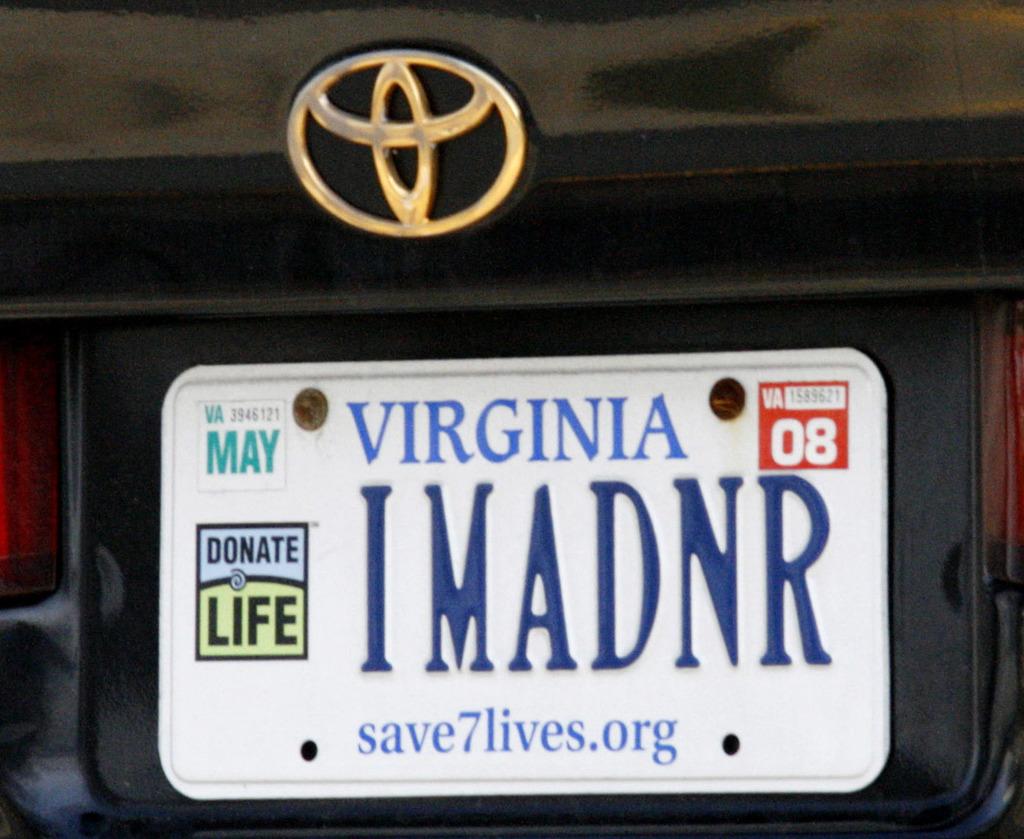What month is on the registration sticker?
Give a very brief answer. May. 